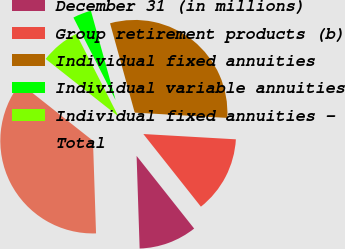Convert chart. <chart><loc_0><loc_0><loc_500><loc_500><pie_chart><fcel>December 31 (in millions)<fcel>Group retirement products (b)<fcel>Individual fixed annuities<fcel>Individual variable annuities<fcel>Individual fixed annuities -<fcel>Total<nl><fcel>10.14%<fcel>13.43%<fcel>30.2%<fcel>3.23%<fcel>6.84%<fcel>36.17%<nl></chart> 